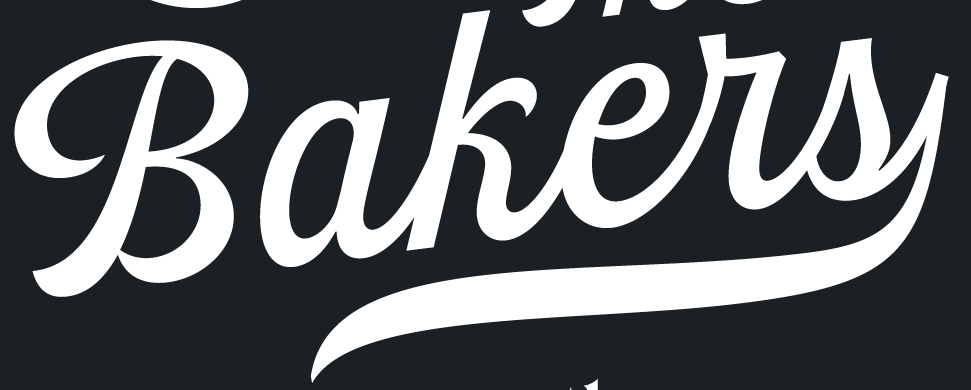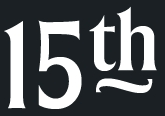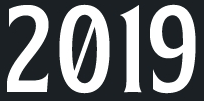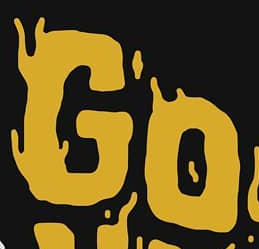What words can you see in these images in sequence, separated by a semicolon? Bakers; 15th; 2019; GO 